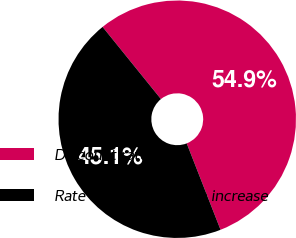<chart> <loc_0><loc_0><loc_500><loc_500><pie_chart><fcel>Discount rate<fcel>Rate of compensation increase<nl><fcel>54.88%<fcel>45.12%<nl></chart> 